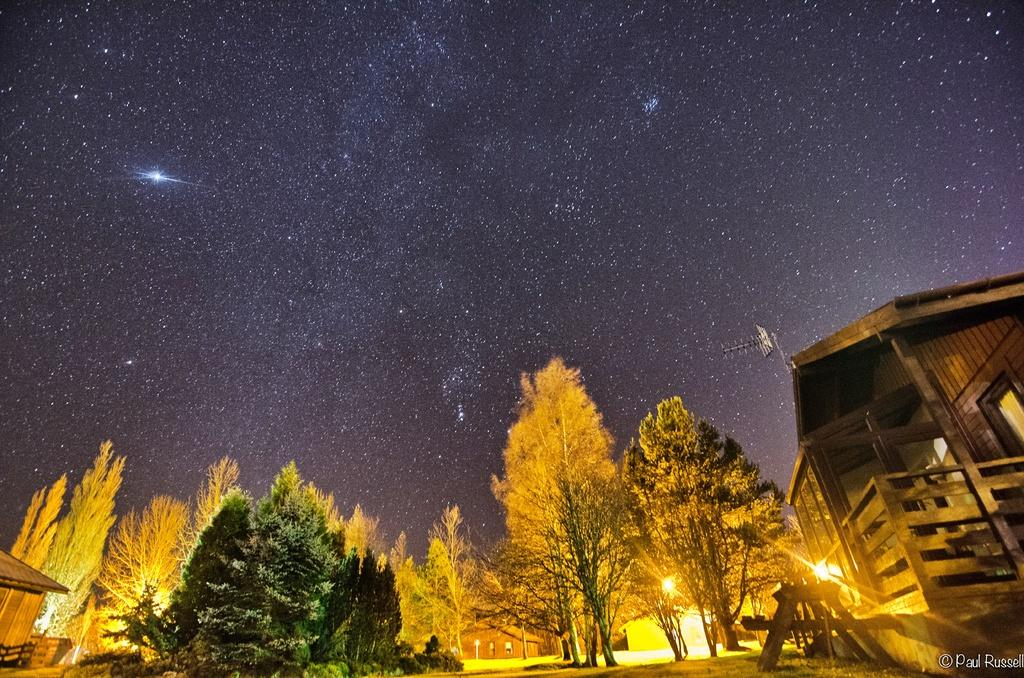What type of vegetation can be seen in the image? There are trees in the image. What type of structures are present in the image? There are houses in the image. What type of seating is available in the image? There is a bench on the ground in the image. What type of illumination is visible in the image? There are lights visible in the image. What can be seen in the background of the image? The sky is visible in the background of the image. How many women are participating in the battle depicted in the image? There is no battle or women present in the image; it features trees, houses, a bench, lights, and the sky. What shape is the bench in the image? The shape of the bench cannot be determined from the image alone, as it only provides a general view of the bench without any specific details about its shape. 